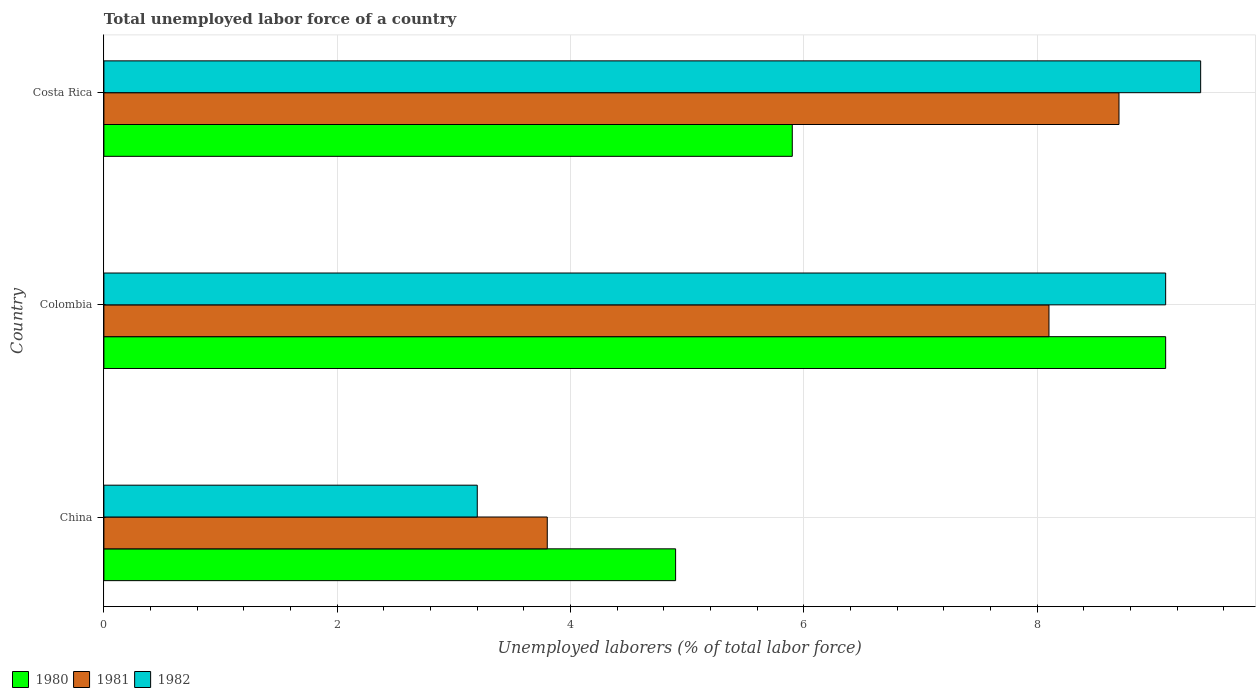How many different coloured bars are there?
Your response must be concise. 3. Are the number of bars on each tick of the Y-axis equal?
Give a very brief answer. Yes. How many bars are there on the 1st tick from the top?
Keep it short and to the point. 3. How many bars are there on the 3rd tick from the bottom?
Provide a short and direct response. 3. What is the label of the 3rd group of bars from the top?
Provide a succinct answer. China. In how many cases, is the number of bars for a given country not equal to the number of legend labels?
Keep it short and to the point. 0. What is the total unemployed labor force in 1981 in Costa Rica?
Keep it short and to the point. 8.7. Across all countries, what is the maximum total unemployed labor force in 1981?
Your answer should be compact. 8.7. Across all countries, what is the minimum total unemployed labor force in 1981?
Your answer should be very brief. 3.8. In which country was the total unemployed labor force in 1980 maximum?
Ensure brevity in your answer.  Colombia. What is the total total unemployed labor force in 1981 in the graph?
Your answer should be compact. 20.6. What is the difference between the total unemployed labor force in 1982 in China and that in Colombia?
Make the answer very short. -5.9. What is the difference between the total unemployed labor force in 1982 in China and the total unemployed labor force in 1981 in Costa Rica?
Ensure brevity in your answer.  -5.5. What is the average total unemployed labor force in 1982 per country?
Give a very brief answer. 7.23. What is the difference between the total unemployed labor force in 1981 and total unemployed labor force in 1982 in China?
Keep it short and to the point. 0.6. In how many countries, is the total unemployed labor force in 1980 greater than 7.6 %?
Provide a succinct answer. 1. What is the ratio of the total unemployed labor force in 1980 in China to that in Colombia?
Offer a very short reply. 0.54. Is the total unemployed labor force in 1982 in China less than that in Costa Rica?
Ensure brevity in your answer.  Yes. Is the difference between the total unemployed labor force in 1981 in Colombia and Costa Rica greater than the difference between the total unemployed labor force in 1982 in Colombia and Costa Rica?
Your answer should be compact. No. What is the difference between the highest and the second highest total unemployed labor force in 1982?
Offer a very short reply. 0.3. What is the difference between the highest and the lowest total unemployed labor force in 1980?
Offer a terse response. 4.2. Is the sum of the total unemployed labor force in 1980 in Colombia and Costa Rica greater than the maximum total unemployed labor force in 1981 across all countries?
Provide a short and direct response. Yes. How many countries are there in the graph?
Give a very brief answer. 3. What is the difference between two consecutive major ticks on the X-axis?
Make the answer very short. 2. Are the values on the major ticks of X-axis written in scientific E-notation?
Offer a very short reply. No. How many legend labels are there?
Offer a very short reply. 3. What is the title of the graph?
Provide a succinct answer. Total unemployed labor force of a country. Does "2000" appear as one of the legend labels in the graph?
Offer a terse response. No. What is the label or title of the X-axis?
Keep it short and to the point. Unemployed laborers (% of total labor force). What is the Unemployed laborers (% of total labor force) of 1980 in China?
Provide a short and direct response. 4.9. What is the Unemployed laborers (% of total labor force) of 1981 in China?
Provide a succinct answer. 3.8. What is the Unemployed laborers (% of total labor force) in 1982 in China?
Make the answer very short. 3.2. What is the Unemployed laborers (% of total labor force) of 1980 in Colombia?
Your answer should be very brief. 9.1. What is the Unemployed laborers (% of total labor force) of 1981 in Colombia?
Offer a terse response. 8.1. What is the Unemployed laborers (% of total labor force) in 1982 in Colombia?
Offer a very short reply. 9.1. What is the Unemployed laborers (% of total labor force) in 1980 in Costa Rica?
Make the answer very short. 5.9. What is the Unemployed laborers (% of total labor force) in 1981 in Costa Rica?
Keep it short and to the point. 8.7. What is the Unemployed laborers (% of total labor force) of 1982 in Costa Rica?
Ensure brevity in your answer.  9.4. Across all countries, what is the maximum Unemployed laborers (% of total labor force) in 1980?
Provide a succinct answer. 9.1. Across all countries, what is the maximum Unemployed laborers (% of total labor force) of 1981?
Provide a short and direct response. 8.7. Across all countries, what is the maximum Unemployed laborers (% of total labor force) in 1982?
Make the answer very short. 9.4. Across all countries, what is the minimum Unemployed laborers (% of total labor force) in 1980?
Your answer should be very brief. 4.9. Across all countries, what is the minimum Unemployed laborers (% of total labor force) in 1981?
Your response must be concise. 3.8. Across all countries, what is the minimum Unemployed laborers (% of total labor force) of 1982?
Provide a succinct answer. 3.2. What is the total Unemployed laborers (% of total labor force) in 1980 in the graph?
Provide a short and direct response. 19.9. What is the total Unemployed laborers (% of total labor force) in 1981 in the graph?
Give a very brief answer. 20.6. What is the total Unemployed laborers (% of total labor force) of 1982 in the graph?
Your response must be concise. 21.7. What is the difference between the Unemployed laborers (% of total labor force) of 1980 in China and that in Colombia?
Your answer should be compact. -4.2. What is the difference between the Unemployed laborers (% of total labor force) of 1981 in China and that in Colombia?
Offer a very short reply. -4.3. What is the difference between the Unemployed laborers (% of total labor force) of 1980 in China and that in Costa Rica?
Your answer should be compact. -1. What is the difference between the Unemployed laborers (% of total labor force) of 1980 in Colombia and that in Costa Rica?
Offer a very short reply. 3.2. What is the difference between the Unemployed laborers (% of total labor force) of 1981 in Colombia and that in Costa Rica?
Offer a very short reply. -0.6. What is the difference between the Unemployed laborers (% of total labor force) of 1982 in Colombia and that in Costa Rica?
Your response must be concise. -0.3. What is the difference between the Unemployed laborers (% of total labor force) of 1980 in China and the Unemployed laborers (% of total labor force) of 1981 in Colombia?
Keep it short and to the point. -3.2. What is the difference between the Unemployed laborers (% of total labor force) of 1980 in China and the Unemployed laborers (% of total labor force) of 1982 in Colombia?
Provide a succinct answer. -4.2. What is the difference between the Unemployed laborers (% of total labor force) of 1981 in China and the Unemployed laborers (% of total labor force) of 1982 in Colombia?
Provide a succinct answer. -5.3. What is the difference between the Unemployed laborers (% of total labor force) of 1980 in Colombia and the Unemployed laborers (% of total labor force) of 1982 in Costa Rica?
Keep it short and to the point. -0.3. What is the difference between the Unemployed laborers (% of total labor force) in 1981 in Colombia and the Unemployed laborers (% of total labor force) in 1982 in Costa Rica?
Provide a succinct answer. -1.3. What is the average Unemployed laborers (% of total labor force) of 1980 per country?
Offer a terse response. 6.63. What is the average Unemployed laborers (% of total labor force) of 1981 per country?
Your response must be concise. 6.87. What is the average Unemployed laborers (% of total labor force) in 1982 per country?
Give a very brief answer. 7.23. What is the difference between the Unemployed laborers (% of total labor force) of 1980 and Unemployed laborers (% of total labor force) of 1981 in China?
Offer a terse response. 1.1. What is the difference between the Unemployed laborers (% of total labor force) of 1980 and Unemployed laborers (% of total labor force) of 1982 in China?
Provide a short and direct response. 1.7. What is the difference between the Unemployed laborers (% of total labor force) of 1980 and Unemployed laborers (% of total labor force) of 1982 in Colombia?
Keep it short and to the point. 0. What is the difference between the Unemployed laborers (% of total labor force) of 1981 and Unemployed laborers (% of total labor force) of 1982 in Colombia?
Give a very brief answer. -1. What is the difference between the Unemployed laborers (% of total labor force) of 1980 and Unemployed laborers (% of total labor force) of 1981 in Costa Rica?
Your response must be concise. -2.8. What is the difference between the Unemployed laborers (% of total labor force) in 1981 and Unemployed laborers (% of total labor force) in 1982 in Costa Rica?
Offer a terse response. -0.7. What is the ratio of the Unemployed laborers (% of total labor force) of 1980 in China to that in Colombia?
Offer a very short reply. 0.54. What is the ratio of the Unemployed laborers (% of total labor force) in 1981 in China to that in Colombia?
Your answer should be compact. 0.47. What is the ratio of the Unemployed laborers (% of total labor force) in 1982 in China to that in Colombia?
Give a very brief answer. 0.35. What is the ratio of the Unemployed laborers (% of total labor force) of 1980 in China to that in Costa Rica?
Your answer should be very brief. 0.83. What is the ratio of the Unemployed laborers (% of total labor force) of 1981 in China to that in Costa Rica?
Keep it short and to the point. 0.44. What is the ratio of the Unemployed laborers (% of total labor force) in 1982 in China to that in Costa Rica?
Ensure brevity in your answer.  0.34. What is the ratio of the Unemployed laborers (% of total labor force) in 1980 in Colombia to that in Costa Rica?
Make the answer very short. 1.54. What is the ratio of the Unemployed laborers (% of total labor force) of 1981 in Colombia to that in Costa Rica?
Provide a succinct answer. 0.93. What is the ratio of the Unemployed laborers (% of total labor force) in 1982 in Colombia to that in Costa Rica?
Provide a short and direct response. 0.97. What is the difference between the highest and the second highest Unemployed laborers (% of total labor force) in 1982?
Provide a succinct answer. 0.3. What is the difference between the highest and the lowest Unemployed laborers (% of total labor force) of 1981?
Make the answer very short. 4.9. What is the difference between the highest and the lowest Unemployed laborers (% of total labor force) in 1982?
Provide a short and direct response. 6.2. 